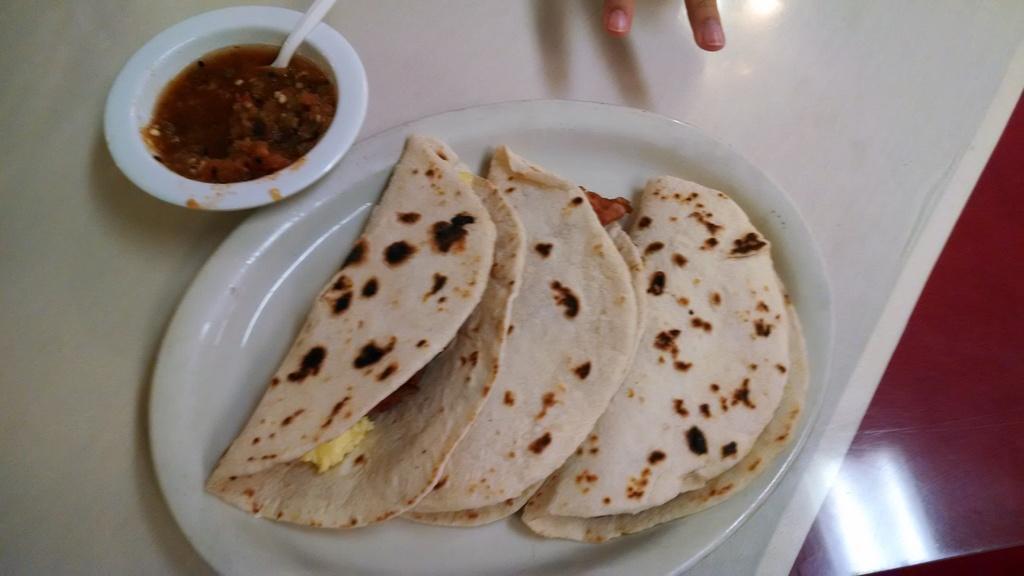Can you describe this image briefly? In this image we can see food in a plate and a bowl with food item and a spoon on a white color platform. At the top of the image we can see two fingers which are truncated. On the right side of the image we can see a red color object. 